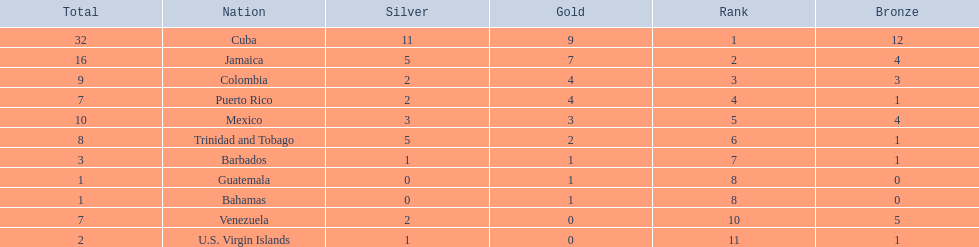Which countries competed in the 1966 central american and caribbean games? Cuba, Jamaica, Colombia, Puerto Rico, Mexico, Trinidad and Tobago, Barbados, Guatemala, Bahamas, Venezuela, U.S. Virgin Islands. Which countries won at least six silver medals at these games? Cuba. 